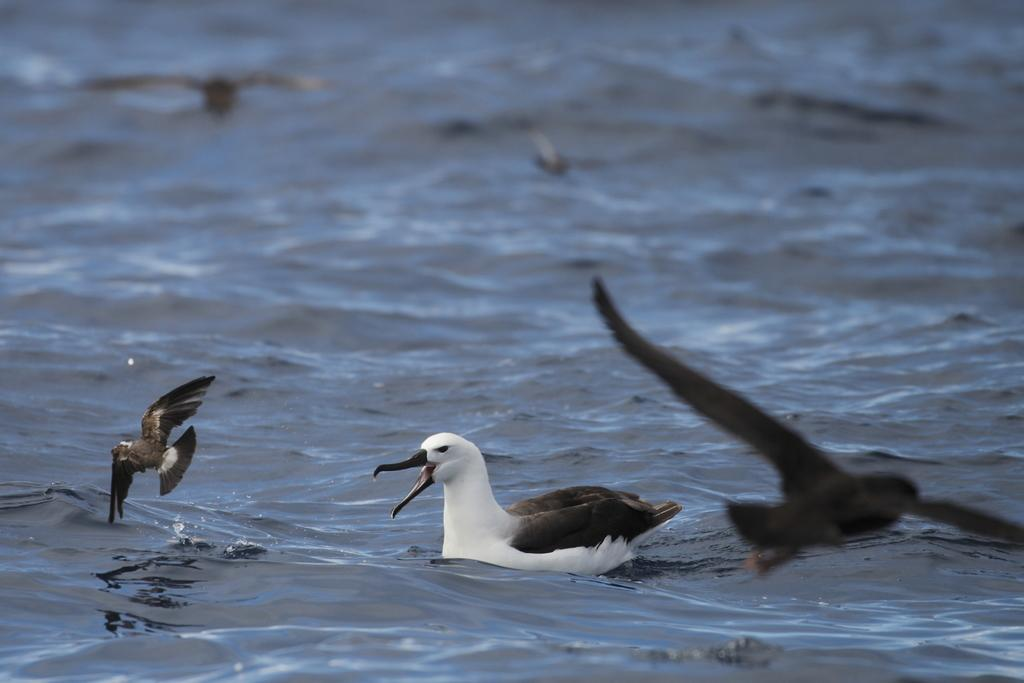What is located on the water in the foreground of the image? There is a bird on the water in the foreground of the image. Can you describe the birds in the image? There are birds on the water and also in the air above the water surface. What type of dirt can be seen on the bird's jeans in the image? There is no bird wearing jeans in the image, and therefore no dirt can be observed on them. 